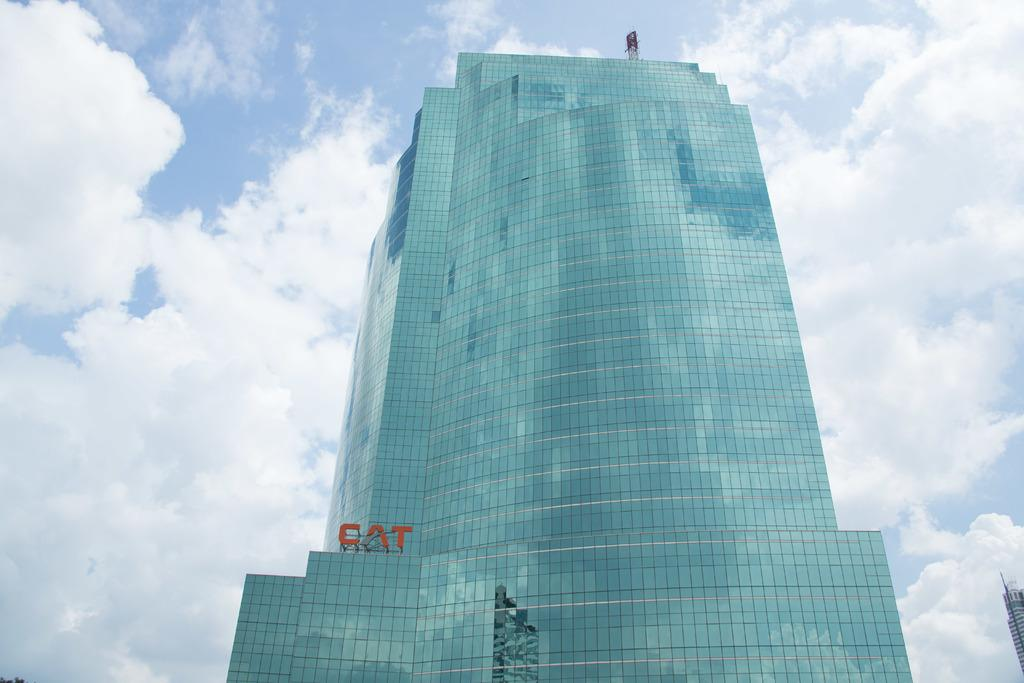<image>
Describe the image concisely. a building outside that has the word CAT on the bottom portion of it 